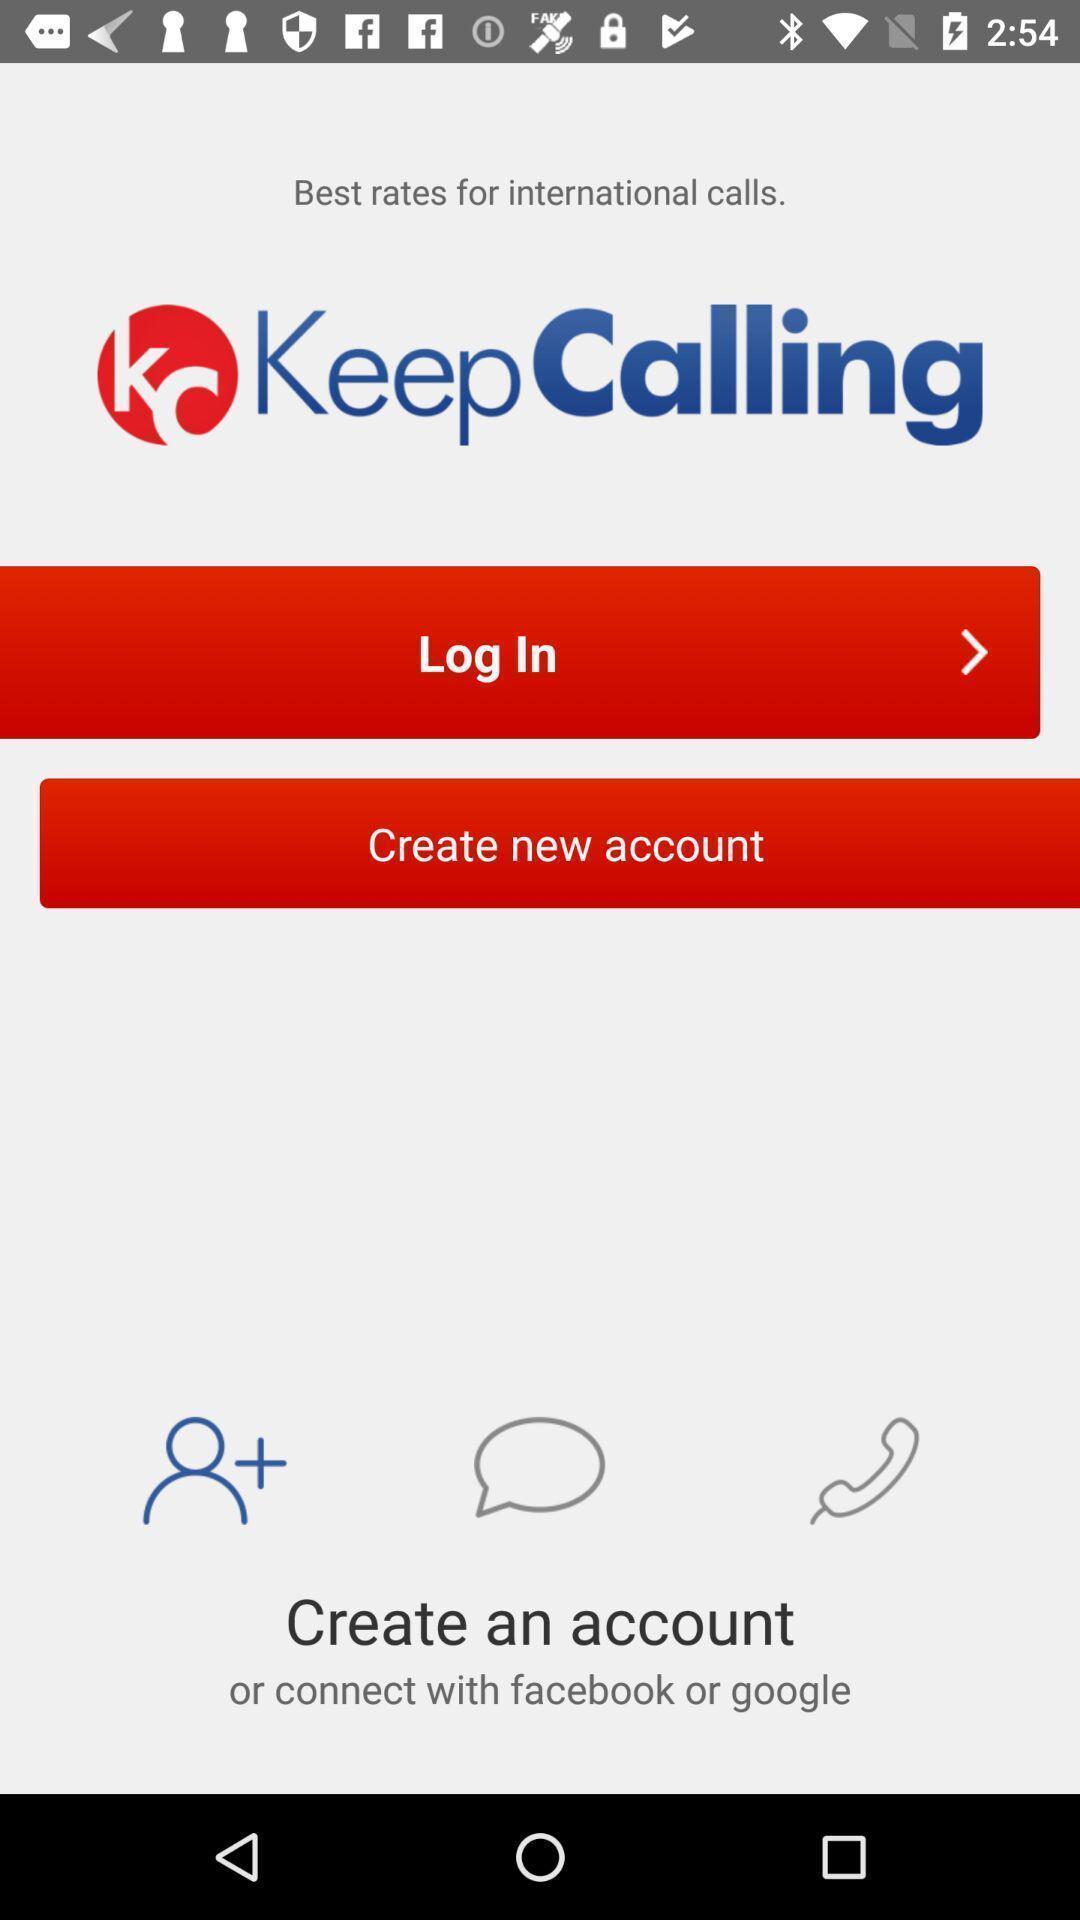Describe the key features of this screenshot. Login page. 